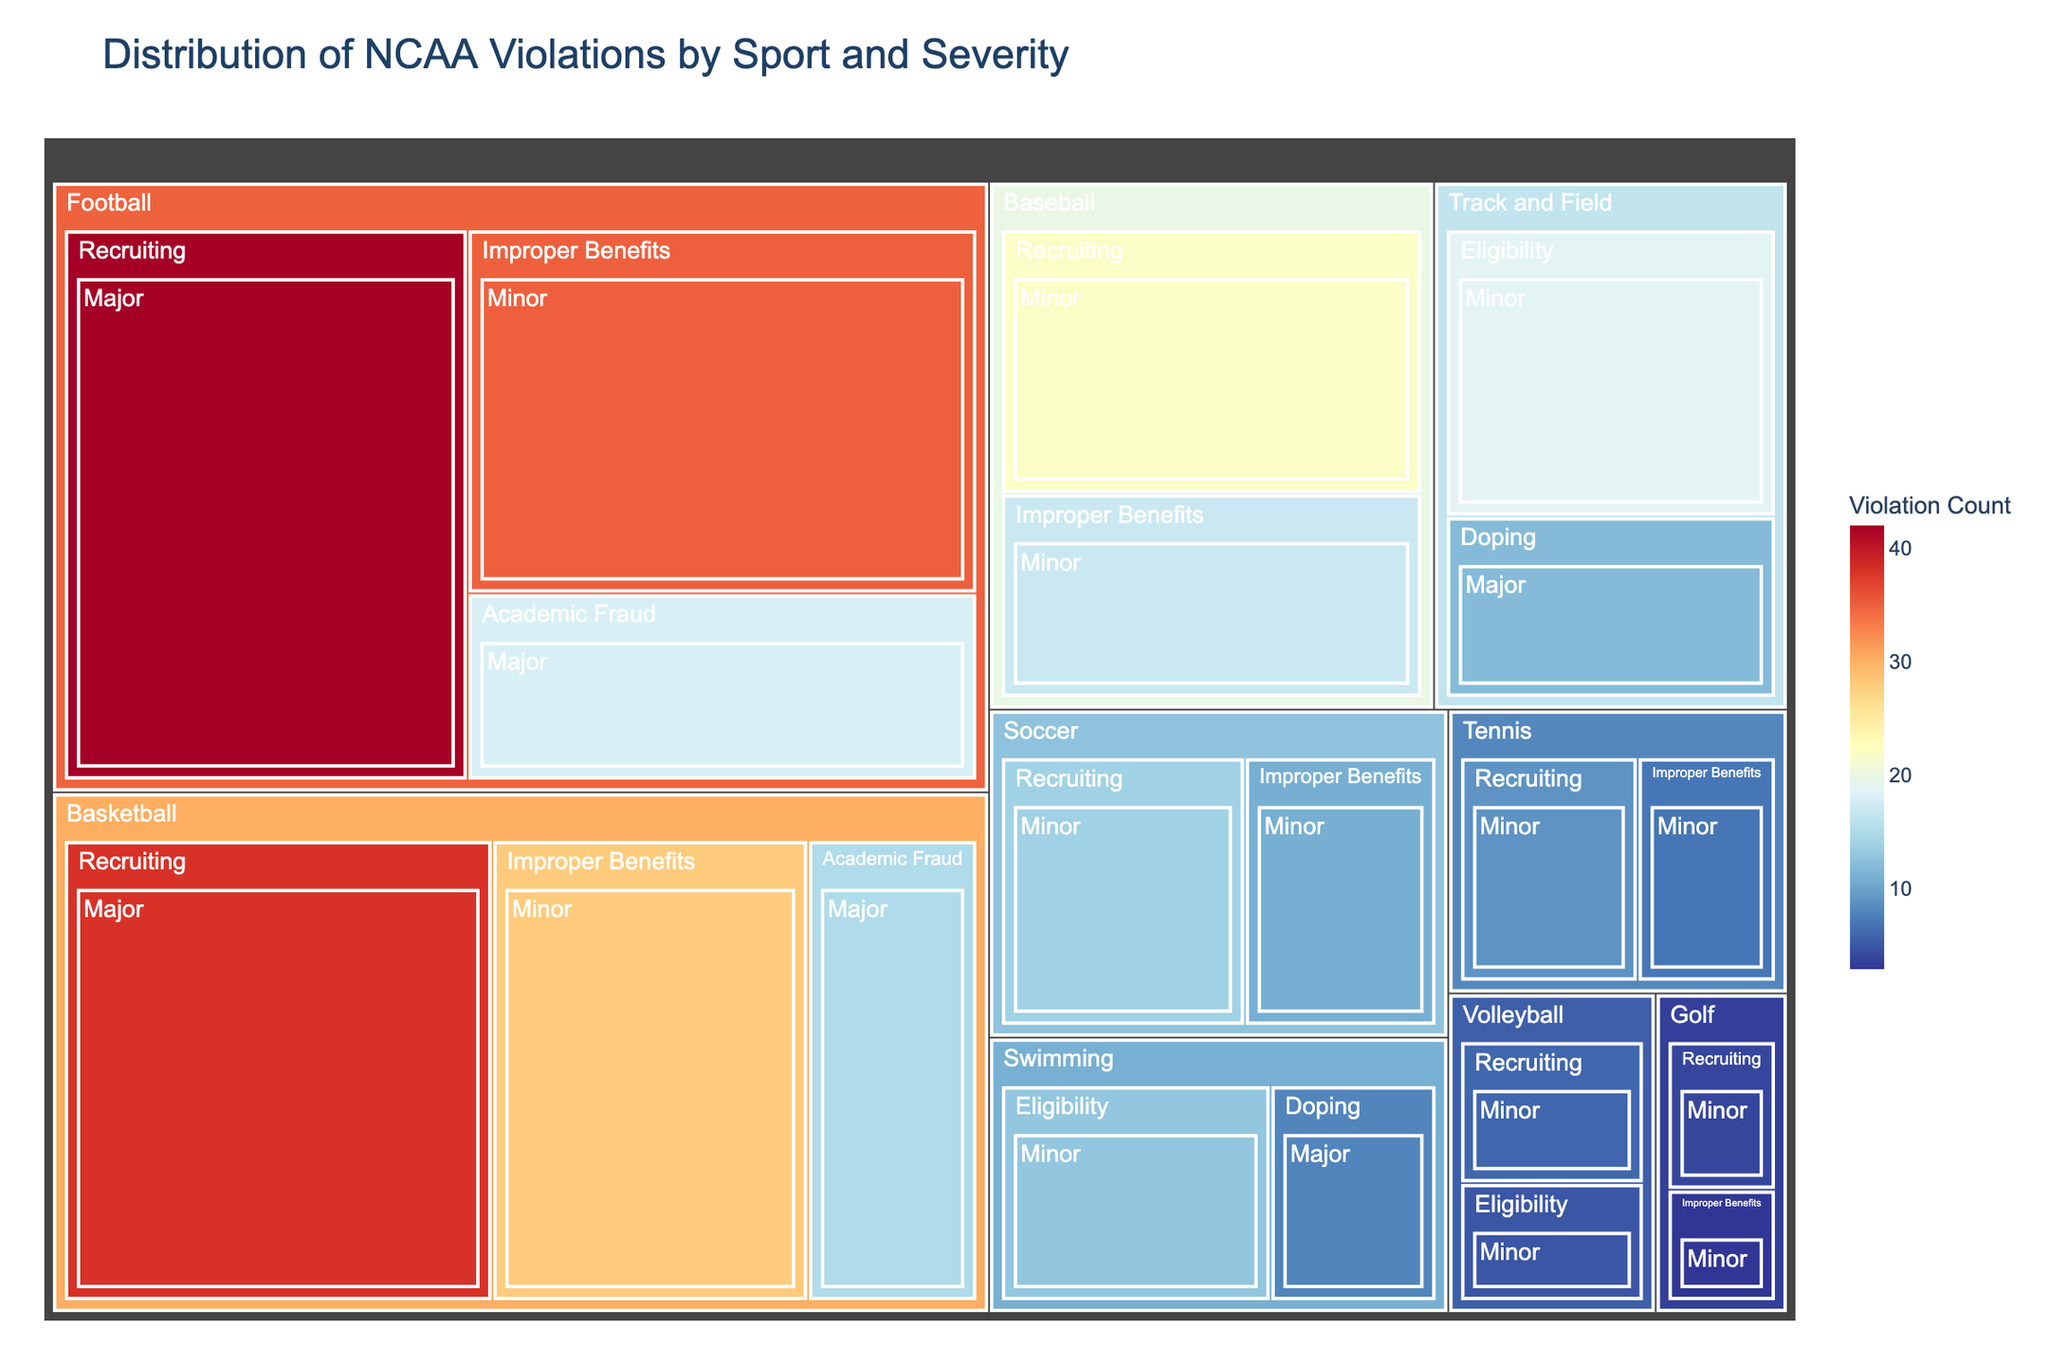What's the title of the figure? The title is often displayed at the top of the figure, indicating the subject of the plot. In this case, the title can be seen clearly.
Answer: Distribution of NCAA Violations by Sport and Severity Which sport has the highest number of major violations? To find this, look for the largest segments under each sport category that are labeled with "Major" severity. The largest segment in terms of size and label count indicates the sport.
Answer: Football How many minor violations are there in total for basketball? Identify all segments under Basketball labeled as "Minor," then sum their counts. For Basketball, the minor violations are related to "Improper Benefits".
Answer: 28 Which violation type is most common in the sport of baseball? Examine the segments under Baseball and compare their sizes and labels. The segment with the largest size and highest count indicates the most common violation.
Answer: Recruiting Is doping more prevalent in track and field or swimming? Compare the sizes and counts of the "Doping" segments for Track and Field and Swimming. The segment with the larger size and higher count has more occurrences.
Answer: Track and Field Which sport has the lowest total number of violations? Assess the overall size and total counts of violation segments for each sport. The sport with the smallest combined segments will have the lowest total number.
Answer: Golf How many major recruiting violations are there in total? Locate all segments labeled with "Recruiting" and "Major," then sum their counts across all sports. For Football and Basketball: 42 + 38.
Answer: 80 What is the total number of academic fraud violations across all sports? Identify all segments labeled as "Academic Fraud" and sum their counts across all related sports. For Football and Basketball: 18 + 15.
Answer: 33 Which sport has the most diverse range of violation types? Count the different types of violations listed under each sport category. The sport with the highest number of different violation types is the answer.
Answer: Football (Recruiting, Academic Fraud, Improper Benefits) What is the total count of violations in the sport of soccer? Sum all segment counts under Soccer. Soccer has "Recruiting" and "Improper Benefits" violations. 14 + 11.
Answer: 25 